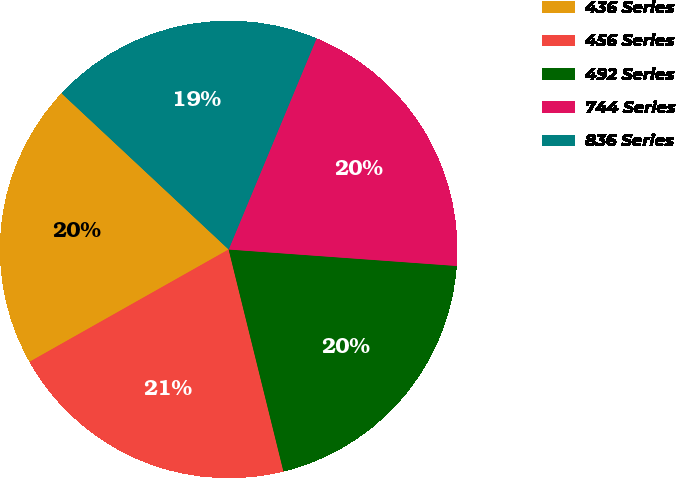<chart> <loc_0><loc_0><loc_500><loc_500><pie_chart><fcel>436 Series<fcel>456 Series<fcel>492 Series<fcel>744 Series<fcel>836 Series<nl><fcel>20.14%<fcel>20.68%<fcel>20.0%<fcel>19.87%<fcel>19.32%<nl></chart> 